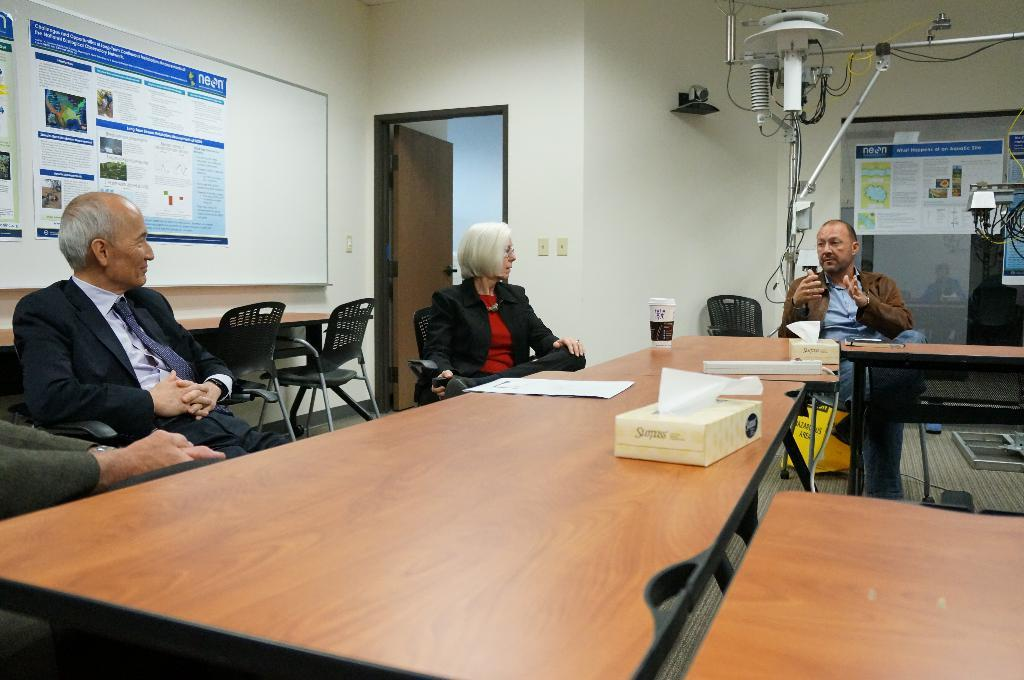What is the main object in the image? There is a board in the image. What other architectural features can be seen in the image? There is a door and a wall in the image. How many people are present in the image? There are three people sitting on chairs in the image. What piece of furniture is present in the image? There is a table in the image. What is the condition of the engine in the image? There is no engine present in the image. How many times has the earth been visited by aliens in the image? There is no reference to the earth or aliens in the image. 